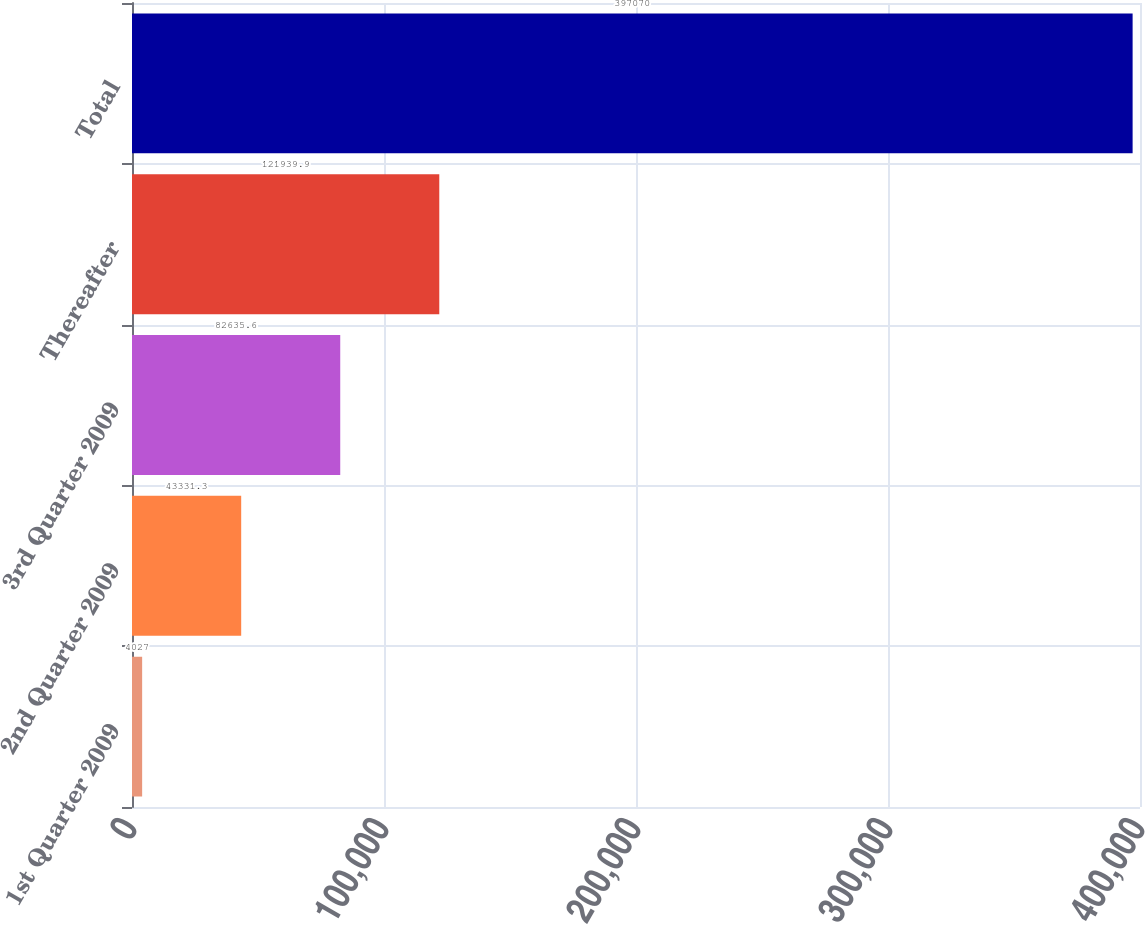Convert chart to OTSL. <chart><loc_0><loc_0><loc_500><loc_500><bar_chart><fcel>1st Quarter 2009<fcel>2nd Quarter 2009<fcel>3rd Quarter 2009<fcel>Thereafter<fcel>Total<nl><fcel>4027<fcel>43331.3<fcel>82635.6<fcel>121940<fcel>397070<nl></chart> 